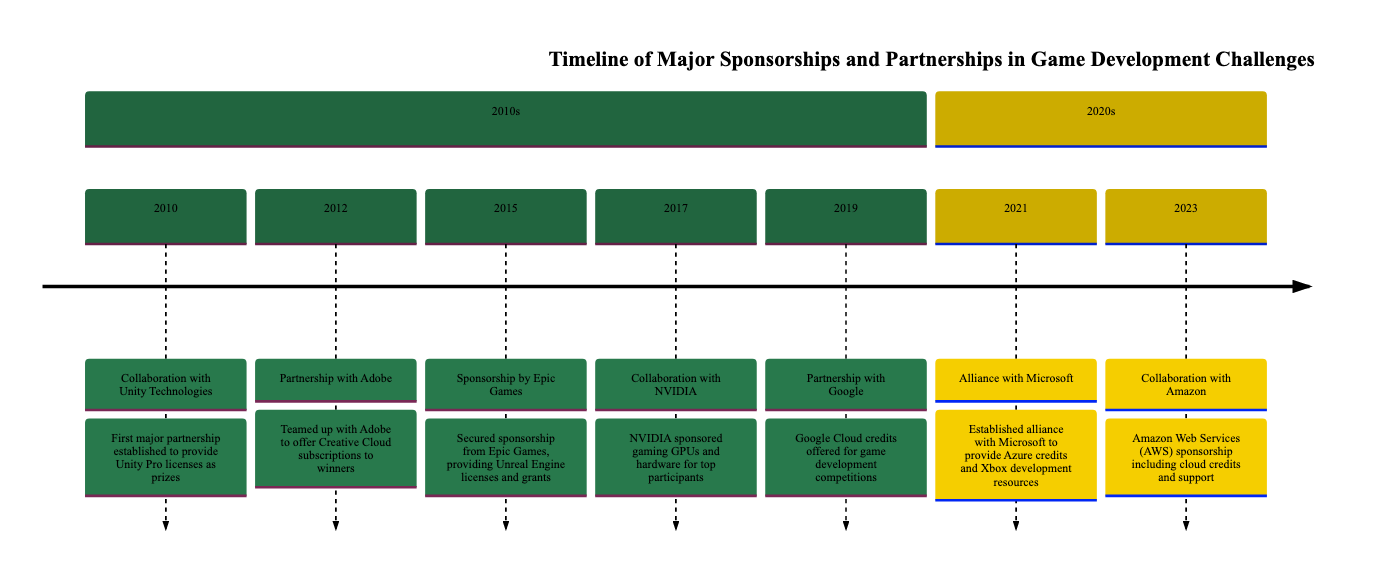What year did the collaboration with Unity Technologies occur? The diagram indicates that the collaboration with Unity Technologies was established in the year 2010, as this event is specifically listed under that year.
Answer: 2010 How many partnerships were established in the 2010s? By scanning the timeline from 2010 to 2019, there are five distinct partnerships listed: Unity Technologies, Adobe, Epic Games, NVIDIA, and Google.
Answer: 5 What is the description of the alliance with Microsoft? Referring to the entry for the year 2021 in the diagram, the description states that the alliance with Microsoft involved providing Azure credits and Xbox development resources to challenge participants.
Answer: Established alliance with Microsoft to provide Azure credits and Xbox development resources Which company sponsored gaming GPUs in 2017? The entry for 2017 clearly states that NVIDIA sponsored gaming GPUs and hardware for the top participants in the game development challenges.
Answer: NVIDIA What major partnership occurred most recently according to the timeline? Scanning the timeline, the most recent event is the collaboration with Amazon in 2023, which is clearly indicated as the last entry in the diagram.
Answer: Collaboration with Amazon Which two companies offered cloud-based resources? Analyzing the timeline, it's evident that Google (in 2019) and Microsoft (in 2021) provided cloud-based resources, as Google Cloud credits and Azure credits were specifically mentioned for those years.
Answer: Google, Microsoft How many years were between the partnership with Adobe and the sponsorship by Epic Games? The partnership with Adobe took place in 2012, and the sponsorship from Epic Games occurred in 2015. The difference in years is 3, calculated by subtracting 2012 from 2015.
Answer: 3 What type of resources did Amazon offer in its collaboration? The timeline for the year 2023 describes that Amazon Web Services (AWS) offered cloud credits and support for game development projects as part of the collaboration.
Answer: Cloud credits and support Which year had the earliest sponsorship listed? The first sponsorship or partnership listed in the timeline is with Unity Technologies in the year 2010, making it the earliest event on the diagram.
Answer: 2010 